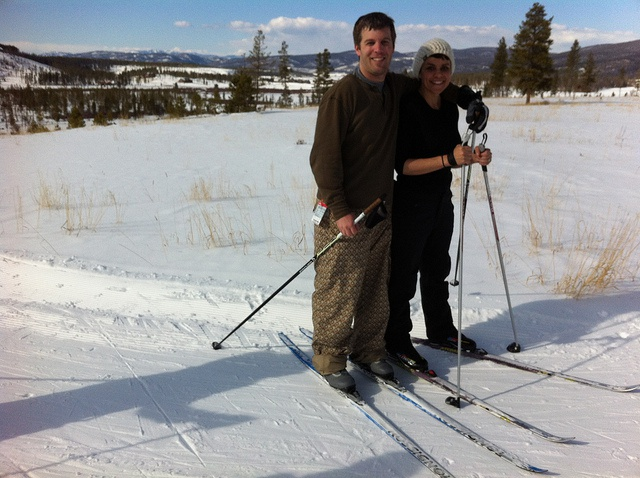Describe the objects in this image and their specific colors. I can see people in gray, black, and maroon tones, people in gray, black, maroon, and darkgray tones, skis in gray, darkgray, black, and lightgray tones, skis in gray, darkgray, and lightgray tones, and skis in gray, black, and darkgray tones in this image. 